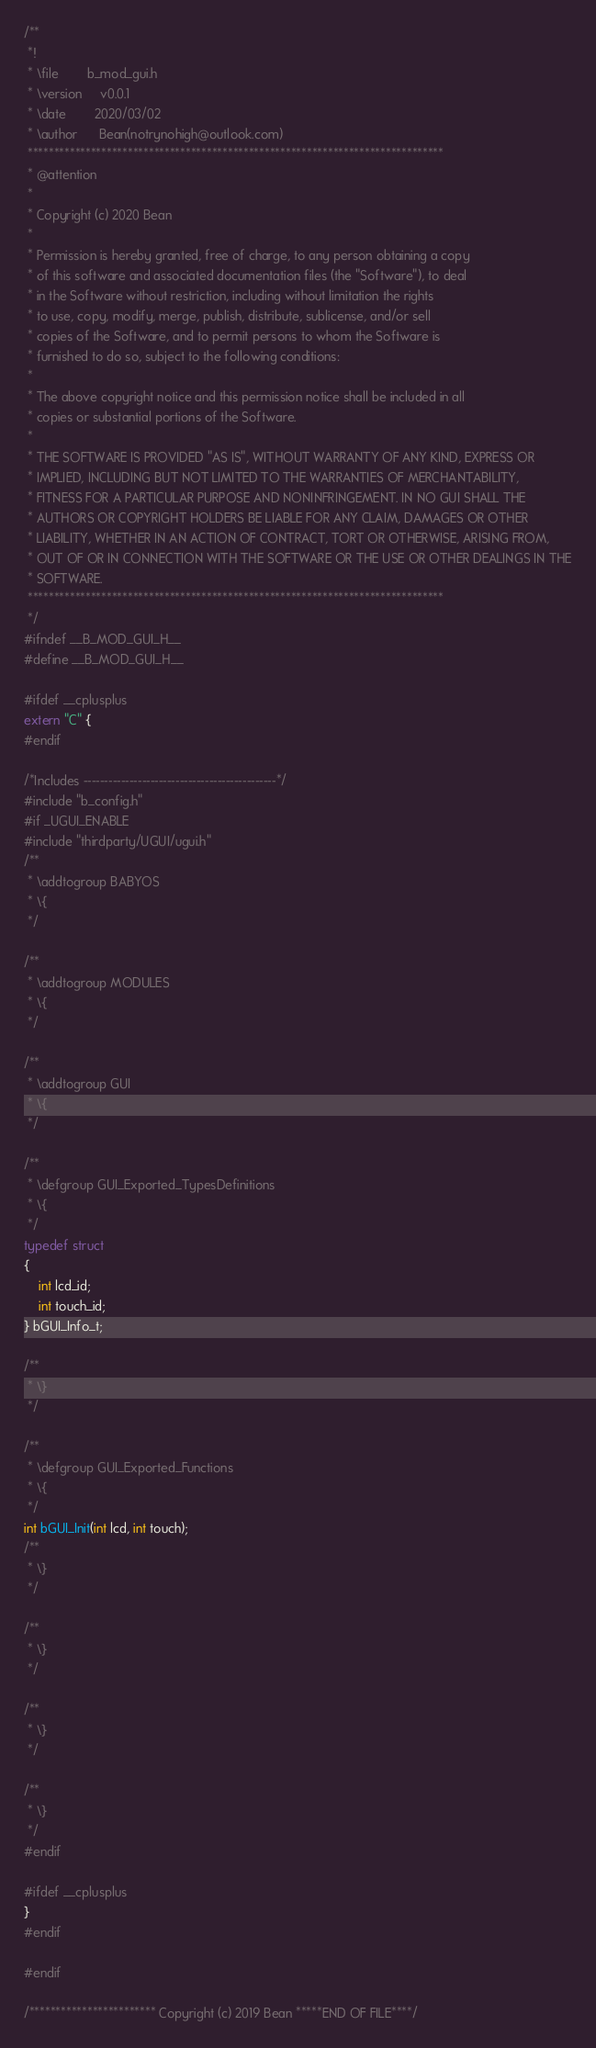Convert code to text. <code><loc_0><loc_0><loc_500><loc_500><_C_>/**
 *!
 * \file        b_mod_gui.h
 * \version     v0.0.1
 * \date        2020/03/02
 * \author      Bean(notrynohigh@outlook.com)
 *******************************************************************************
 * @attention
 *
 * Copyright (c) 2020 Bean
 *
 * Permission is hereby granted, free of charge, to any person obtaining a copy
 * of this software and associated documentation files (the "Software"), to deal
 * in the Software without restriction, including without limitation the rights
 * to use, copy, modify, merge, publish, distribute, sublicense, and/or sell
 * copies of the Software, and to permit persons to whom the Software is
 * furnished to do so, subject to the following conditions:
 *
 * The above copyright notice and this permission notice shall be included in all
 * copies or substantial portions of the Software.
 *
 * THE SOFTWARE IS PROVIDED "AS IS", WITHOUT WARRANTY OF ANY KIND, EXPRESS OR
 * IMPLIED, INCLUDING BUT NOT LIMITED TO THE WARRANTIES OF MERCHANTABILITY,
 * FITNESS FOR A PARTICULAR PURPOSE AND NONINFRINGEMENT. IN NO GUI SHALL THE
 * AUTHORS OR COPYRIGHT HOLDERS BE LIABLE FOR ANY CLAIM, DAMAGES OR OTHER
 * LIABILITY, WHETHER IN AN ACTION OF CONTRACT, TORT OR OTHERWISE, ARISING FROM,
 * OUT OF OR IN CONNECTION WITH THE SOFTWARE OR THE USE OR OTHER DEALINGS IN THE
 * SOFTWARE.
 *******************************************************************************
 */
#ifndef __B_MOD_GUI_H__
#define __B_MOD_GUI_H__

#ifdef __cplusplus
extern "C" {
#endif

/*Includes ----------------------------------------------*/
#include "b_config.h"
#if _UGUI_ENABLE
#include "thirdparty/UGUI/ugui.h"
/**
 * \addtogroup BABYOS
 * \{
 */

/**
 * \addtogroup MODULES
 * \{
 */

/**
 * \addtogroup GUI
 * \{
 */

/**
 * \defgroup GUI_Exported_TypesDefinitions
 * \{
 */
typedef struct
{
    int lcd_id;
    int touch_id;
} bGUI_Info_t;

/**
 * \}
 */

/**
 * \defgroup GUI_Exported_Functions
 * \{
 */
int bGUI_Init(int lcd, int touch);
/**
 * \}
 */

/**
 * \}
 */

/**
 * \}
 */

/**
 * \}
 */
#endif

#ifdef __cplusplus
}
#endif

#endif

/************************ Copyright (c) 2019 Bean *****END OF FILE****/
</code> 